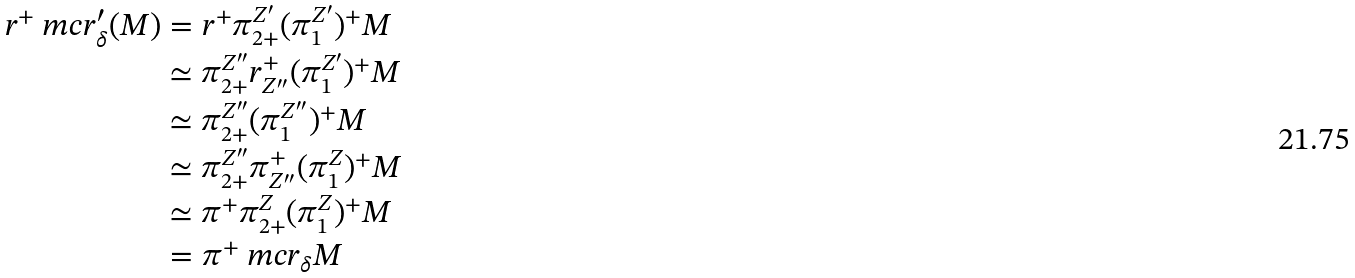Convert formula to latex. <formula><loc_0><loc_0><loc_500><loc_500>r ^ { + } \ m c r ^ { \prime } _ { \delta } ( M ) & = r ^ { + } \pi _ { 2 + } ^ { Z ^ { \prime } } ( \pi _ { 1 } ^ { Z ^ { \prime } } ) ^ { + } M \\ & \simeq \pi _ { 2 + } ^ { Z ^ { \prime \prime } } r _ { Z ^ { \prime \prime } } ^ { + } ( \pi _ { 1 } ^ { Z ^ { \prime } } ) ^ { + } M \\ & \simeq \pi _ { 2 + } ^ { Z ^ { \prime \prime } } ( \pi _ { 1 } ^ { Z ^ { \prime \prime } } ) ^ { + } M \\ & \simeq \pi _ { 2 + } ^ { Z ^ { \prime \prime } } \pi _ { Z ^ { \prime \prime } } ^ { + } ( \pi _ { 1 } ^ { Z } ) ^ { + } M \\ & \simeq \pi ^ { + } \pi _ { 2 + } ^ { Z } ( \pi _ { 1 } ^ { Z } ) ^ { + } M \\ & = \pi ^ { + } \ m c r _ { \delta } M</formula> 